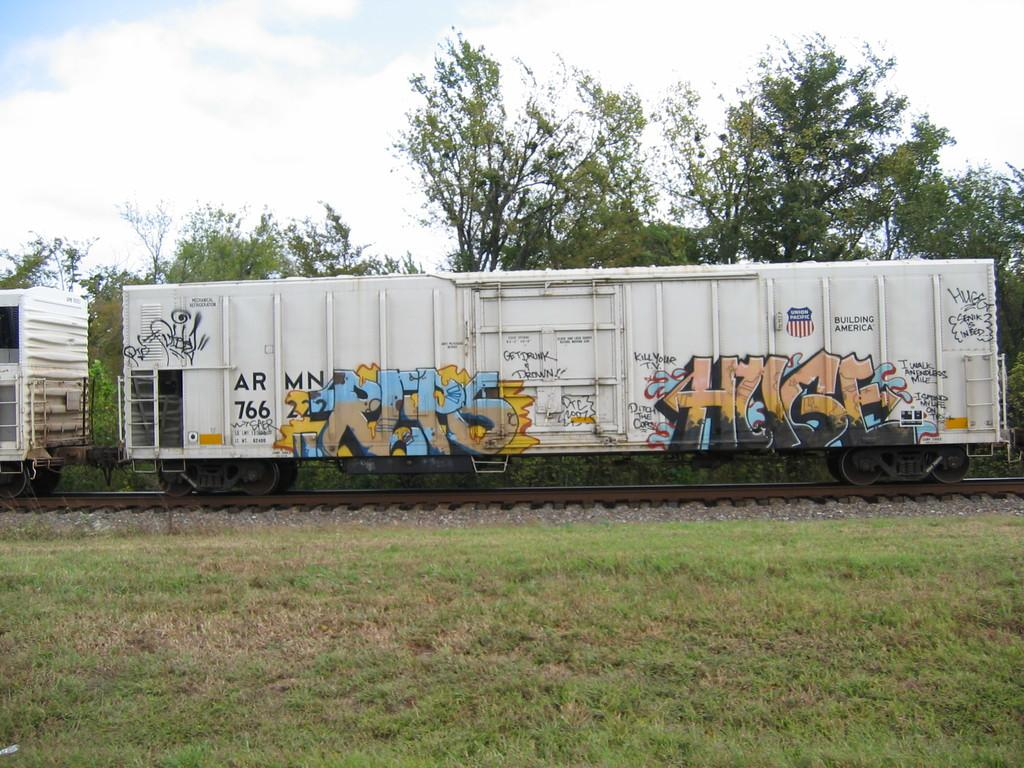What is the main subject of the image? The main subject of the image is a train. Where is the train located in the image? The train is on a railway track. What can be seen in the background of the image? Trees are present behind the train, and the sky is covered with clouds. What type of terrain is visible at the bottom of the image? The bottom of the image contains grassy land. How many goats are present in the image? There are no goats present in the image; it features a train on a railway track with trees, clouds, and grassy land in the background. 